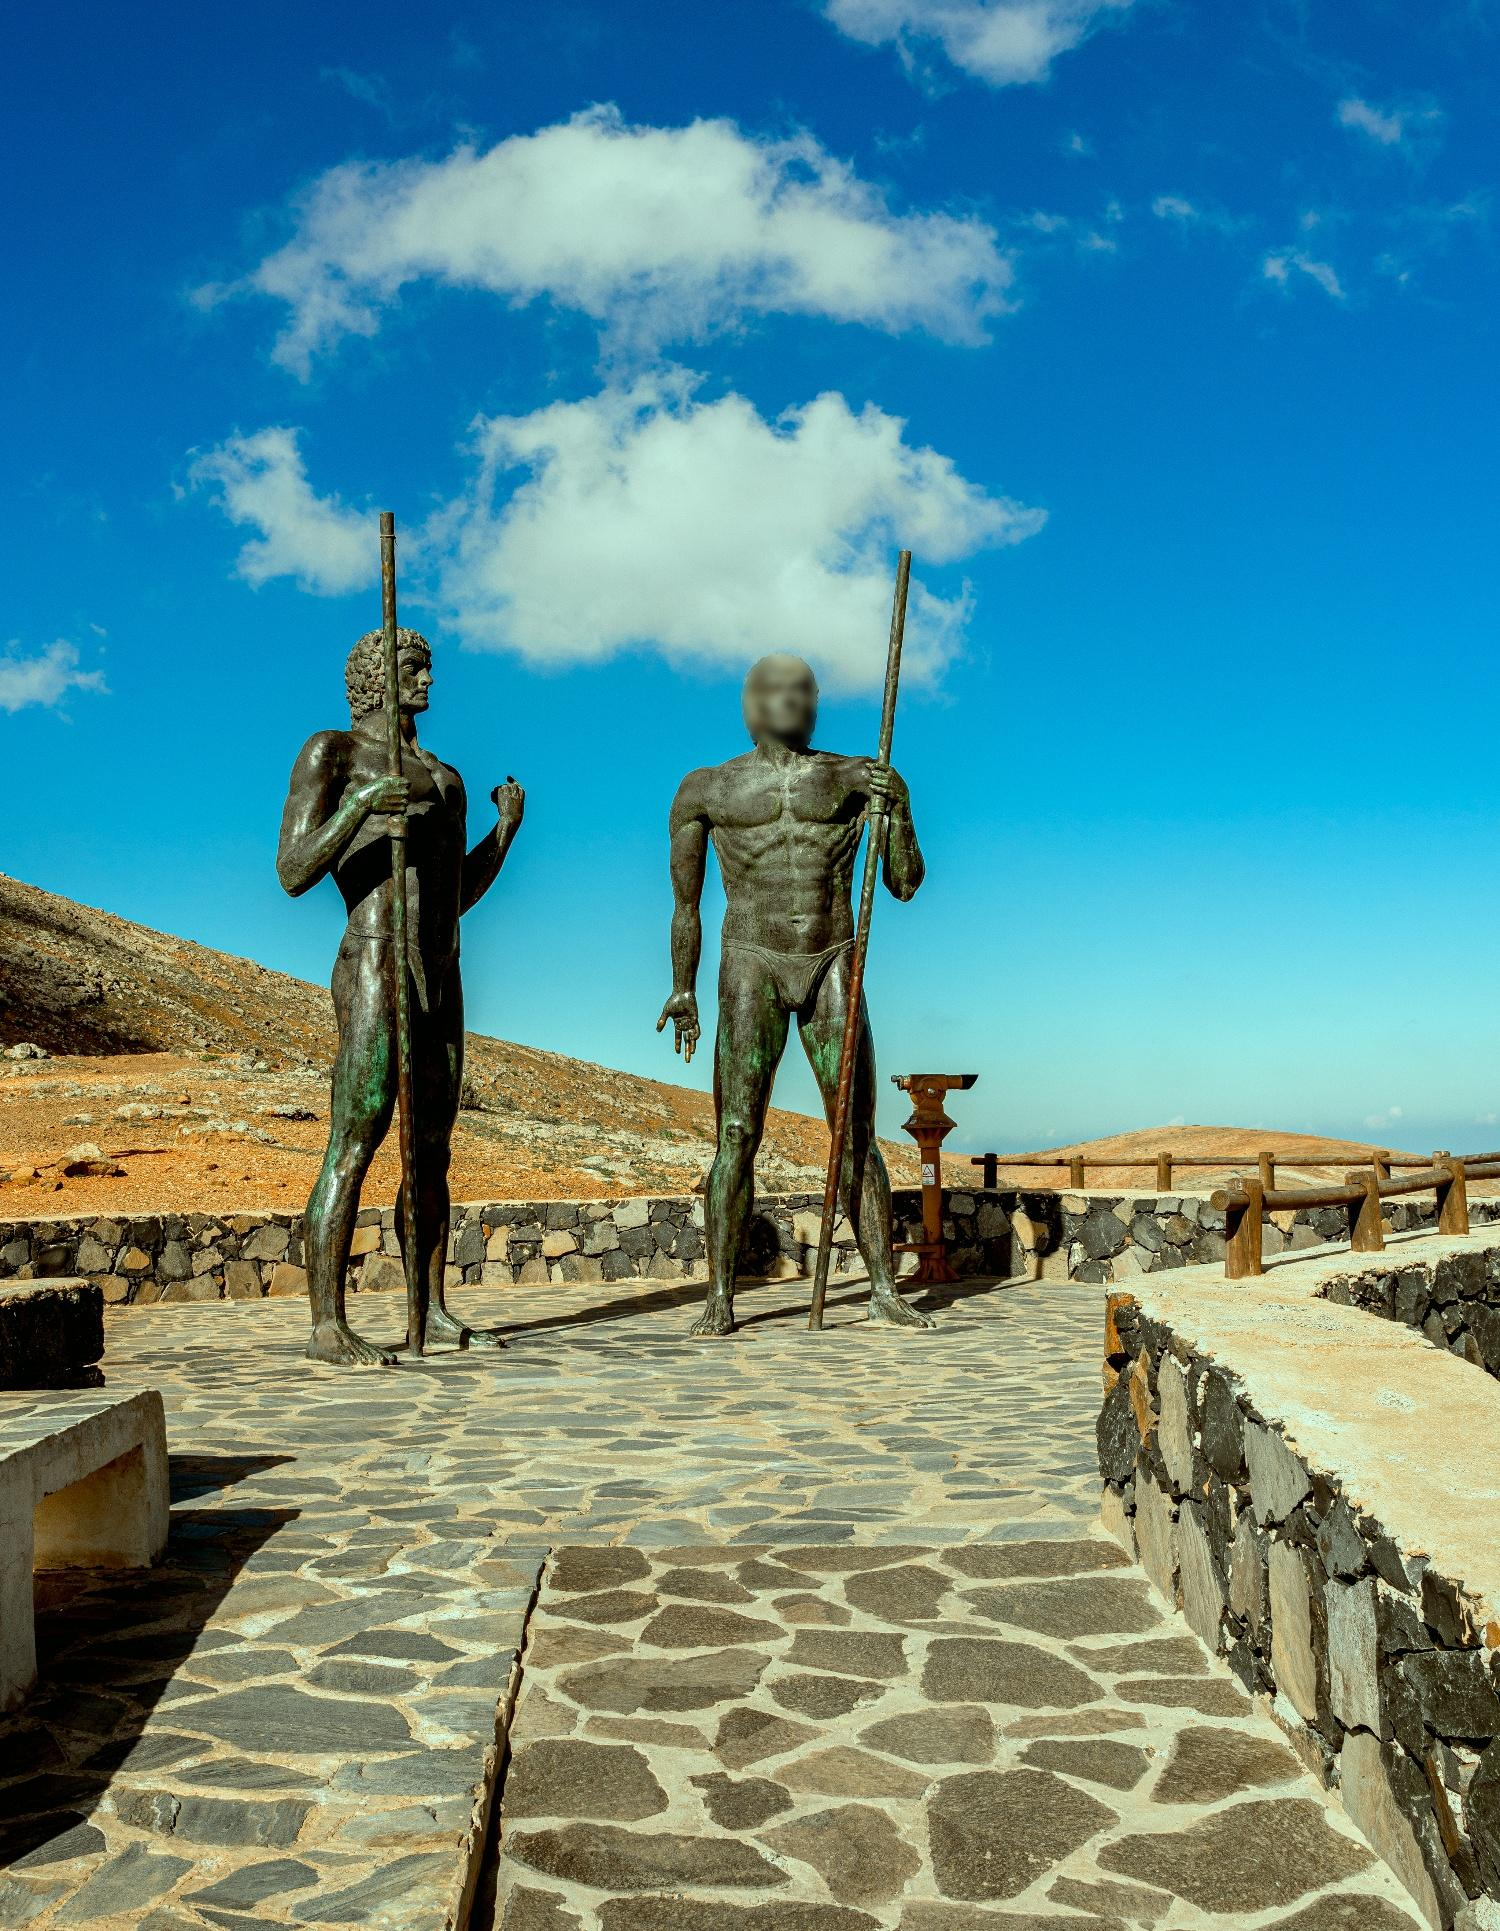What do you see happening in this image? The image displays two imposing bronze statues, possibly representing ancient warriors, standing on a cobblestone path. One statue wields a spear, and the other carries a shield, both exuding an aura of readiness and strength. This scene is set against a stark, desert-like landscape with a vivid blue sky overhead. The statues are positioned as if guarding the path, which is flanked by a rustic stone wall, suggesting that this may be a site of historical or memorial significance. The photograph is taken from a low angle, emphasizing the statues' towering and heroic stature against the expansive backdrop. 